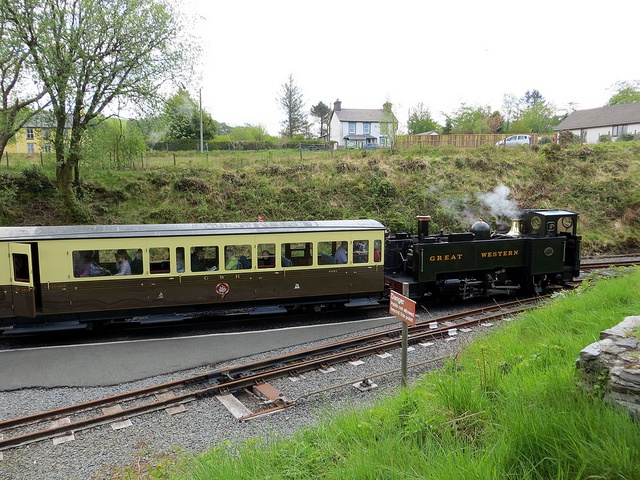Describe the objects in this image and their specific colors. I can see train in olive, black, tan, gray, and darkgray tones, people in olive, black, gray, and darkblue tones, people in olive, black, and gray tones, car in olive, lightgray, darkgray, tan, and gray tones, and people in olive, black, gray, and darkgray tones in this image. 